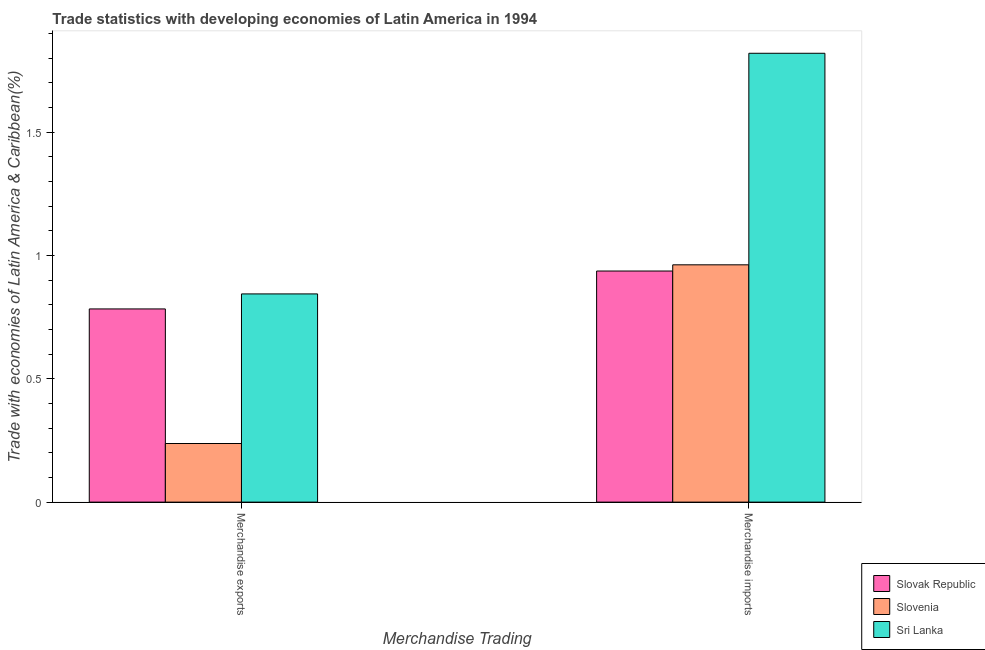How many different coloured bars are there?
Offer a terse response. 3. How many groups of bars are there?
Offer a terse response. 2. Are the number of bars on each tick of the X-axis equal?
Make the answer very short. Yes. How many bars are there on the 1st tick from the right?
Provide a succinct answer. 3. What is the label of the 2nd group of bars from the left?
Ensure brevity in your answer.  Merchandise imports. What is the merchandise imports in Sri Lanka?
Your response must be concise. 1.82. Across all countries, what is the maximum merchandise exports?
Your answer should be compact. 0.84. Across all countries, what is the minimum merchandise exports?
Your answer should be compact. 0.24. In which country was the merchandise imports maximum?
Offer a terse response. Sri Lanka. In which country was the merchandise imports minimum?
Your response must be concise. Slovak Republic. What is the total merchandise imports in the graph?
Provide a succinct answer. 3.72. What is the difference between the merchandise imports in Slovenia and that in Sri Lanka?
Your answer should be compact. -0.86. What is the difference between the merchandise imports in Slovenia and the merchandise exports in Slovak Republic?
Provide a succinct answer. 0.18. What is the average merchandise exports per country?
Provide a short and direct response. 0.62. What is the difference between the merchandise exports and merchandise imports in Slovak Republic?
Offer a very short reply. -0.15. In how many countries, is the merchandise exports greater than 0.30000000000000004 %?
Provide a succinct answer. 2. What is the ratio of the merchandise exports in Slovenia to that in Slovak Republic?
Provide a succinct answer. 0.3. Is the merchandise imports in Sri Lanka less than that in Slovenia?
Make the answer very short. No. In how many countries, is the merchandise exports greater than the average merchandise exports taken over all countries?
Ensure brevity in your answer.  2. What does the 2nd bar from the left in Merchandise exports represents?
Provide a short and direct response. Slovenia. What does the 2nd bar from the right in Merchandise imports represents?
Offer a terse response. Slovenia. How many bars are there?
Give a very brief answer. 6. What is the difference between two consecutive major ticks on the Y-axis?
Keep it short and to the point. 0.5. Are the values on the major ticks of Y-axis written in scientific E-notation?
Your response must be concise. No. Does the graph contain any zero values?
Your response must be concise. No. What is the title of the graph?
Keep it short and to the point. Trade statistics with developing economies of Latin America in 1994. What is the label or title of the X-axis?
Offer a terse response. Merchandise Trading. What is the label or title of the Y-axis?
Offer a terse response. Trade with economies of Latin America & Caribbean(%). What is the Trade with economies of Latin America & Caribbean(%) of Slovak Republic in Merchandise exports?
Offer a terse response. 0.78. What is the Trade with economies of Latin America & Caribbean(%) in Slovenia in Merchandise exports?
Keep it short and to the point. 0.24. What is the Trade with economies of Latin America & Caribbean(%) in Sri Lanka in Merchandise exports?
Offer a very short reply. 0.84. What is the Trade with economies of Latin America & Caribbean(%) of Slovak Republic in Merchandise imports?
Offer a very short reply. 0.94. What is the Trade with economies of Latin America & Caribbean(%) in Slovenia in Merchandise imports?
Keep it short and to the point. 0.96. What is the Trade with economies of Latin America & Caribbean(%) in Sri Lanka in Merchandise imports?
Offer a terse response. 1.82. Across all Merchandise Trading, what is the maximum Trade with economies of Latin America & Caribbean(%) of Slovak Republic?
Give a very brief answer. 0.94. Across all Merchandise Trading, what is the maximum Trade with economies of Latin America & Caribbean(%) in Slovenia?
Your answer should be very brief. 0.96. Across all Merchandise Trading, what is the maximum Trade with economies of Latin America & Caribbean(%) in Sri Lanka?
Your answer should be compact. 1.82. Across all Merchandise Trading, what is the minimum Trade with economies of Latin America & Caribbean(%) of Slovak Republic?
Offer a terse response. 0.78. Across all Merchandise Trading, what is the minimum Trade with economies of Latin America & Caribbean(%) of Slovenia?
Offer a terse response. 0.24. Across all Merchandise Trading, what is the minimum Trade with economies of Latin America & Caribbean(%) in Sri Lanka?
Your response must be concise. 0.84. What is the total Trade with economies of Latin America & Caribbean(%) in Slovak Republic in the graph?
Your answer should be compact. 1.72. What is the total Trade with economies of Latin America & Caribbean(%) in Slovenia in the graph?
Your answer should be very brief. 1.2. What is the total Trade with economies of Latin America & Caribbean(%) of Sri Lanka in the graph?
Your answer should be very brief. 2.66. What is the difference between the Trade with economies of Latin America & Caribbean(%) of Slovak Republic in Merchandise exports and that in Merchandise imports?
Your answer should be compact. -0.15. What is the difference between the Trade with economies of Latin America & Caribbean(%) in Slovenia in Merchandise exports and that in Merchandise imports?
Ensure brevity in your answer.  -0.72. What is the difference between the Trade with economies of Latin America & Caribbean(%) in Sri Lanka in Merchandise exports and that in Merchandise imports?
Provide a succinct answer. -0.98. What is the difference between the Trade with economies of Latin America & Caribbean(%) of Slovak Republic in Merchandise exports and the Trade with economies of Latin America & Caribbean(%) of Slovenia in Merchandise imports?
Provide a short and direct response. -0.18. What is the difference between the Trade with economies of Latin America & Caribbean(%) in Slovak Republic in Merchandise exports and the Trade with economies of Latin America & Caribbean(%) in Sri Lanka in Merchandise imports?
Provide a succinct answer. -1.04. What is the difference between the Trade with economies of Latin America & Caribbean(%) in Slovenia in Merchandise exports and the Trade with economies of Latin America & Caribbean(%) in Sri Lanka in Merchandise imports?
Give a very brief answer. -1.58. What is the average Trade with economies of Latin America & Caribbean(%) in Slovak Republic per Merchandise Trading?
Provide a short and direct response. 0.86. What is the average Trade with economies of Latin America & Caribbean(%) of Slovenia per Merchandise Trading?
Offer a terse response. 0.6. What is the average Trade with economies of Latin America & Caribbean(%) in Sri Lanka per Merchandise Trading?
Give a very brief answer. 1.33. What is the difference between the Trade with economies of Latin America & Caribbean(%) in Slovak Republic and Trade with economies of Latin America & Caribbean(%) in Slovenia in Merchandise exports?
Offer a terse response. 0.55. What is the difference between the Trade with economies of Latin America & Caribbean(%) in Slovak Republic and Trade with economies of Latin America & Caribbean(%) in Sri Lanka in Merchandise exports?
Provide a succinct answer. -0.06. What is the difference between the Trade with economies of Latin America & Caribbean(%) in Slovenia and Trade with economies of Latin America & Caribbean(%) in Sri Lanka in Merchandise exports?
Give a very brief answer. -0.61. What is the difference between the Trade with economies of Latin America & Caribbean(%) of Slovak Republic and Trade with economies of Latin America & Caribbean(%) of Slovenia in Merchandise imports?
Offer a terse response. -0.03. What is the difference between the Trade with economies of Latin America & Caribbean(%) of Slovak Republic and Trade with economies of Latin America & Caribbean(%) of Sri Lanka in Merchandise imports?
Keep it short and to the point. -0.88. What is the difference between the Trade with economies of Latin America & Caribbean(%) in Slovenia and Trade with economies of Latin America & Caribbean(%) in Sri Lanka in Merchandise imports?
Provide a short and direct response. -0.86. What is the ratio of the Trade with economies of Latin America & Caribbean(%) of Slovak Republic in Merchandise exports to that in Merchandise imports?
Your answer should be very brief. 0.84. What is the ratio of the Trade with economies of Latin America & Caribbean(%) in Slovenia in Merchandise exports to that in Merchandise imports?
Provide a succinct answer. 0.25. What is the ratio of the Trade with economies of Latin America & Caribbean(%) of Sri Lanka in Merchandise exports to that in Merchandise imports?
Keep it short and to the point. 0.46. What is the difference between the highest and the second highest Trade with economies of Latin America & Caribbean(%) in Slovak Republic?
Your response must be concise. 0.15. What is the difference between the highest and the second highest Trade with economies of Latin America & Caribbean(%) of Slovenia?
Offer a very short reply. 0.72. What is the difference between the highest and the second highest Trade with economies of Latin America & Caribbean(%) in Sri Lanka?
Provide a succinct answer. 0.98. What is the difference between the highest and the lowest Trade with economies of Latin America & Caribbean(%) of Slovak Republic?
Your response must be concise. 0.15. What is the difference between the highest and the lowest Trade with economies of Latin America & Caribbean(%) of Slovenia?
Give a very brief answer. 0.72. What is the difference between the highest and the lowest Trade with economies of Latin America & Caribbean(%) in Sri Lanka?
Keep it short and to the point. 0.98. 